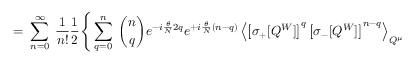<formula> <loc_0><loc_0><loc_500><loc_500>= \, \sum _ { n = 0 } ^ { \infty } \, \frac { 1 } { n ! } \frac { 1 } { 2 } \Big \{ \sum _ { q = 0 } ^ { n } \, { \binom { n } { q } } e ^ { - i \frac { \theta } { N } 2 q } e ^ { + i \frac { \theta } { N } ( n - q ) } \left \langle \left [ \sigma _ { + } [ Q ^ { W } ] \right ] ^ { q } \left [ \sigma _ { - } [ Q ^ { W } ] \right ] ^ { n - q } \right \rangle _ { Q ^ { \mu } }</formula> 